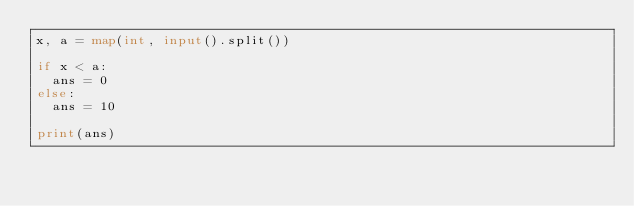Convert code to text. <code><loc_0><loc_0><loc_500><loc_500><_Python_>x, a = map(int, input().split())

if x < a:
  ans = 0
else:
  ans = 10
  
print(ans)</code> 